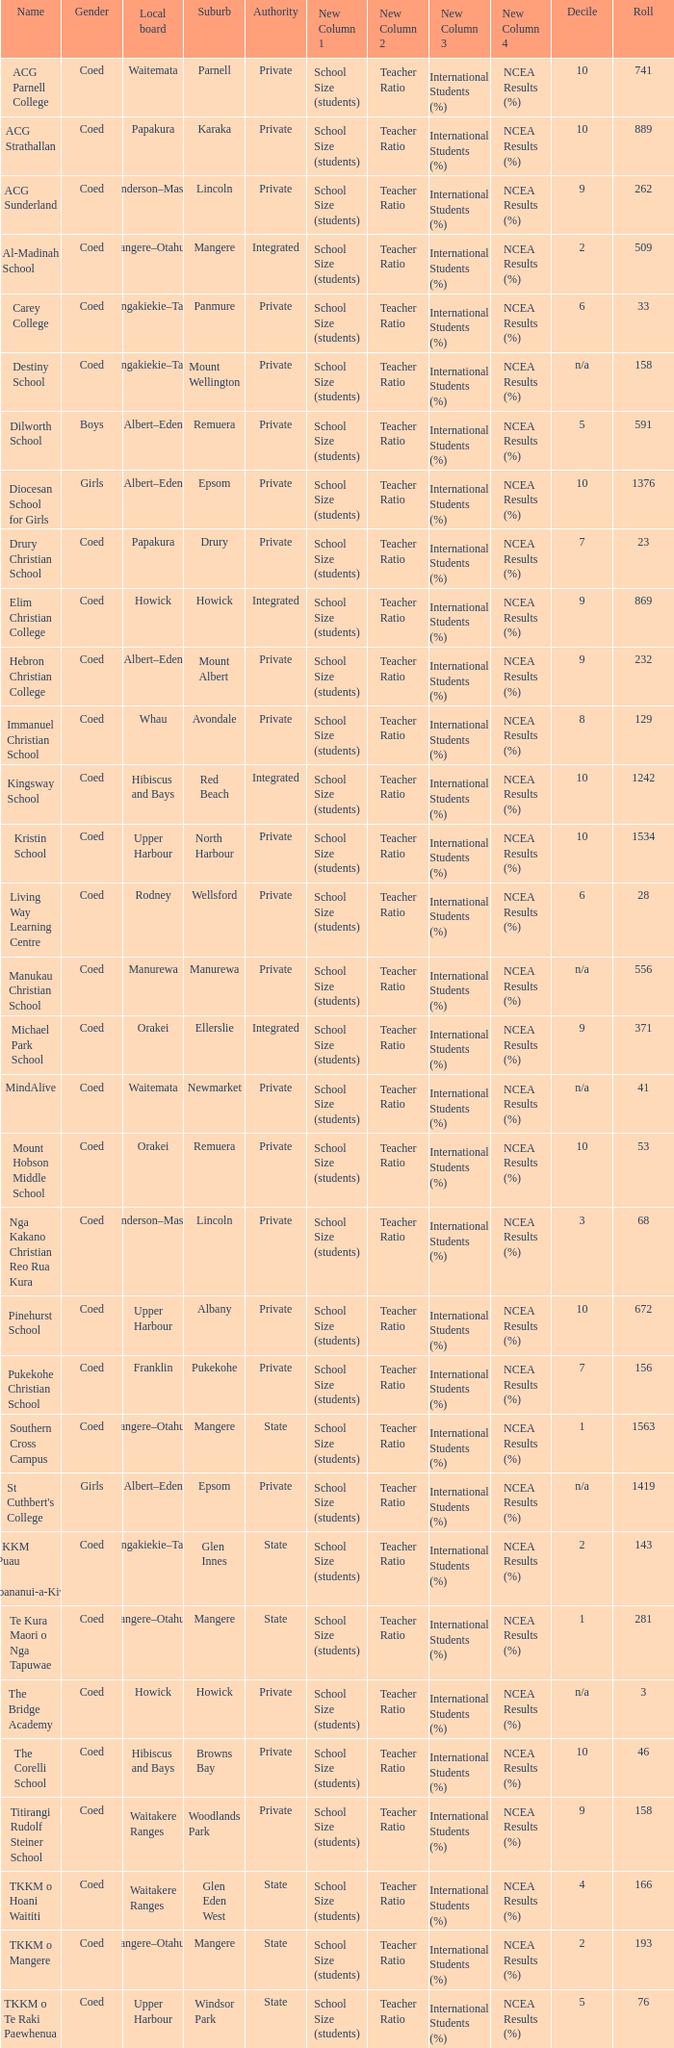What is the name when the local board is albert–eden, and a Decile of 9? Hebron Christian College. 